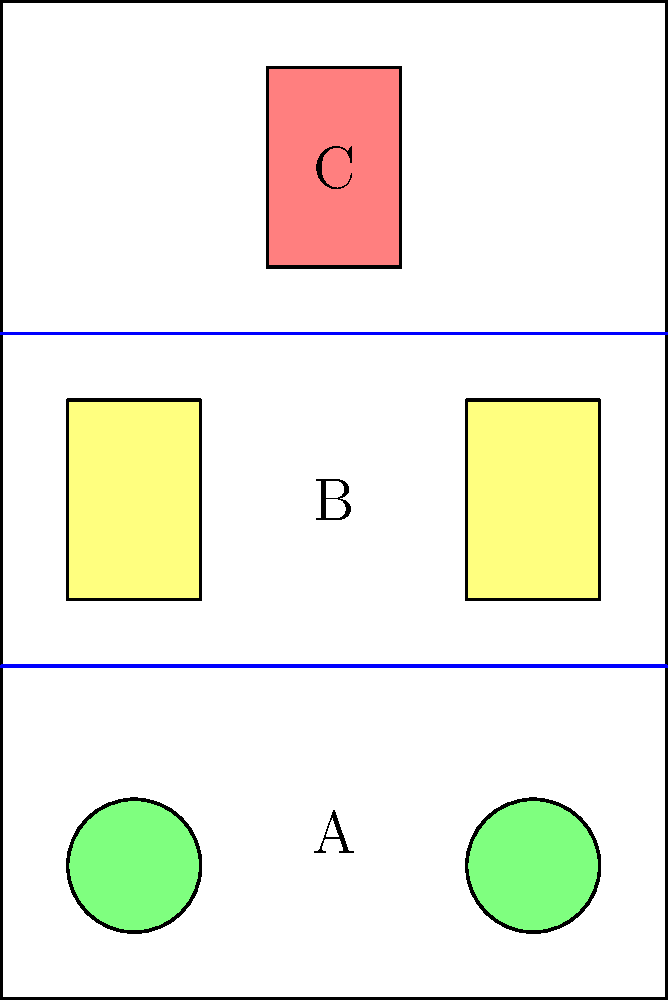In the diagram above, a refrigerator is divided into three sections (A, B, and C) by two shelves. Given that circular items (e.g., fruits) are best stored in section A, rectangular items (e.g., containers) in section B, and tall items (e.g., bottles) in section C, what is the optimal ratio of heights for sections A:B:C to maximize storage efficiency while accommodating these item types? To determine the optimal ratio of heights for sections A, B, and C, we need to consider the typical sizes of items stored in each section and the frequency of their use. Let's analyze step-by-step:

1. Section A (bottom):
   - Stores circular items like fruits
   - Typically shorter in height
   - Needs easy access for frequent use

2. Section B (middle):
   - Stores rectangular containers
   - Medium height required
   - Moderate access frequency

3. Section C (top):
   - Stores tall items like bottles
   - Requires the most vertical space
   - Less frequent access

Considering these factors:

1. Section A should be approximately 25% of the total height:
   - Allows stacking of 2-3 layers of fruits
   - Provides easy access for frequently used items

2. Section B should be about 35% of the total height:
   - Accommodates various sizes of rectangular containers
   - Allows for some stacking while maintaining visibility

3. Section C should take up about 40% of the total height:
   - Provides ample space for tall bottles and less frequently used items
   - Utilizes upper space efficiently

This distribution maximizes storage efficiency by allocating space proportional to the height requirements and usage frequency of different item types.

The optimal ratio can be expressed as A:B:C = 25:35:40 or simplified to 5:7:8.
Answer: 5:7:8 